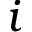<formula> <loc_0><loc_0><loc_500><loc_500>i</formula> 